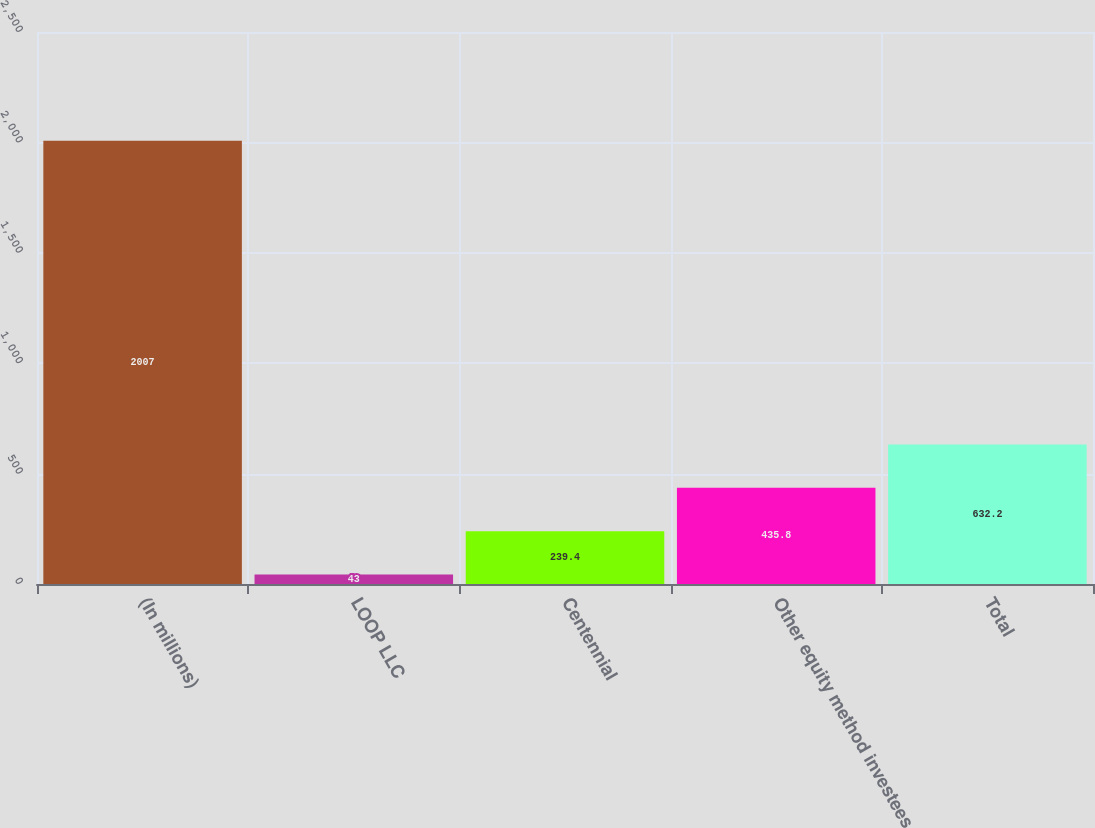Convert chart to OTSL. <chart><loc_0><loc_0><loc_500><loc_500><bar_chart><fcel>(In millions)<fcel>LOOP LLC<fcel>Centennial<fcel>Other equity method investees<fcel>Total<nl><fcel>2007<fcel>43<fcel>239.4<fcel>435.8<fcel>632.2<nl></chart> 